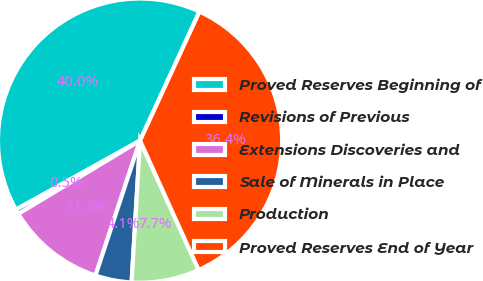Convert chart to OTSL. <chart><loc_0><loc_0><loc_500><loc_500><pie_chart><fcel>Proved Reserves Beginning of<fcel>Revisions of Previous<fcel>Extensions Discoveries and<fcel>Sale of Minerals in Place<fcel>Production<fcel>Proved Reserves End of Year<nl><fcel>39.95%<fcel>0.54%<fcel>11.3%<fcel>4.13%<fcel>7.72%<fcel>36.36%<nl></chart> 